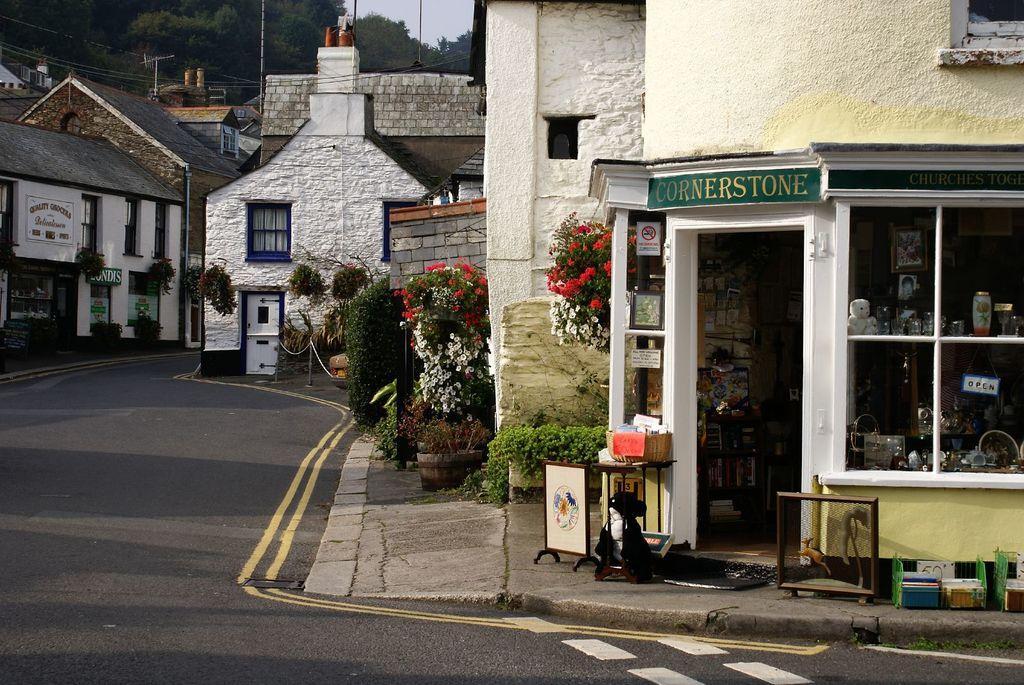In one or two sentences, can you explain what this image depicts? In this picture I can see many buildings. Beside that I can see some flowers on the plants. In the background I can see the poles, electric wires, trees and sky. On the left I can see the road. 